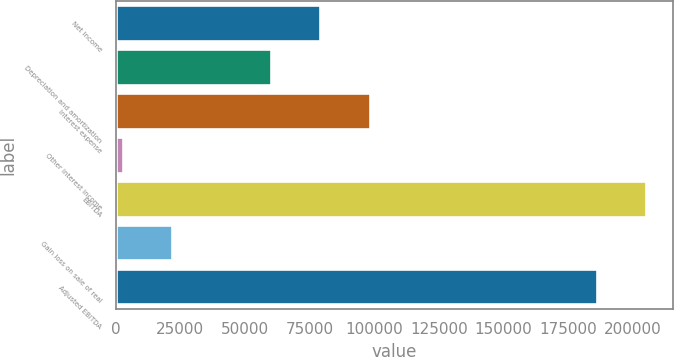Convert chart. <chart><loc_0><loc_0><loc_500><loc_500><bar_chart><fcel>Net income<fcel>Depreciation and amortization<fcel>Interest expense<fcel>Other interest income<fcel>EBITDA<fcel>Gain loss on sale of real<fcel>Adjusted EBITDA<nl><fcel>79179.9<fcel>59914<fcel>98445.8<fcel>2662<fcel>205402<fcel>21927.9<fcel>186136<nl></chart> 